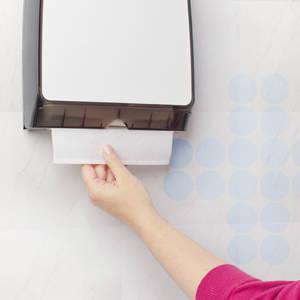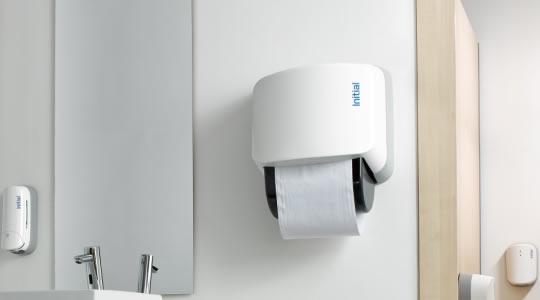The first image is the image on the left, the second image is the image on the right. For the images displayed, is the sentence "A hand is reaching toward a white towel in a dispenser." factually correct? Answer yes or no. Yes. The first image is the image on the left, the second image is the image on the right. For the images displayed, is the sentence "The image on the left shows a human hand holding a paper towel." factually correct? Answer yes or no. Yes. 